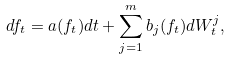<formula> <loc_0><loc_0><loc_500><loc_500>d f _ { t } = a ( f _ { t } ) d t + \sum _ { j = 1 } ^ { m } b _ { j } ( f _ { t } ) d W _ { t } ^ { j } ,</formula> 